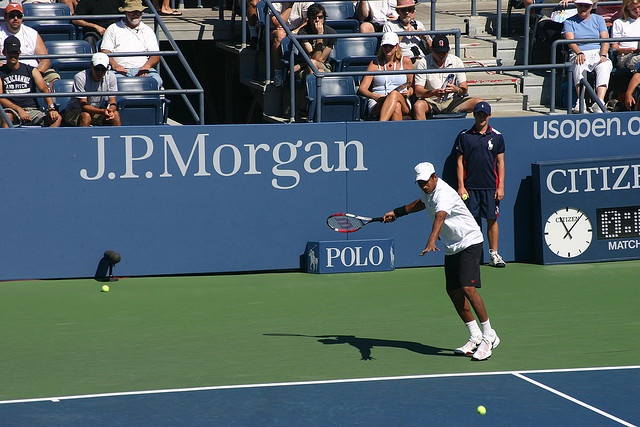Describe the objects in this image and their specific colors. I can see people in black, white, gray, and blue tones, people in black, navy, brown, and salmon tones, people in black, brown, gray, and darkgray tones, people in black, white, darkgray, and gray tones, and people in black, white, darkgray, and gray tones in this image. 